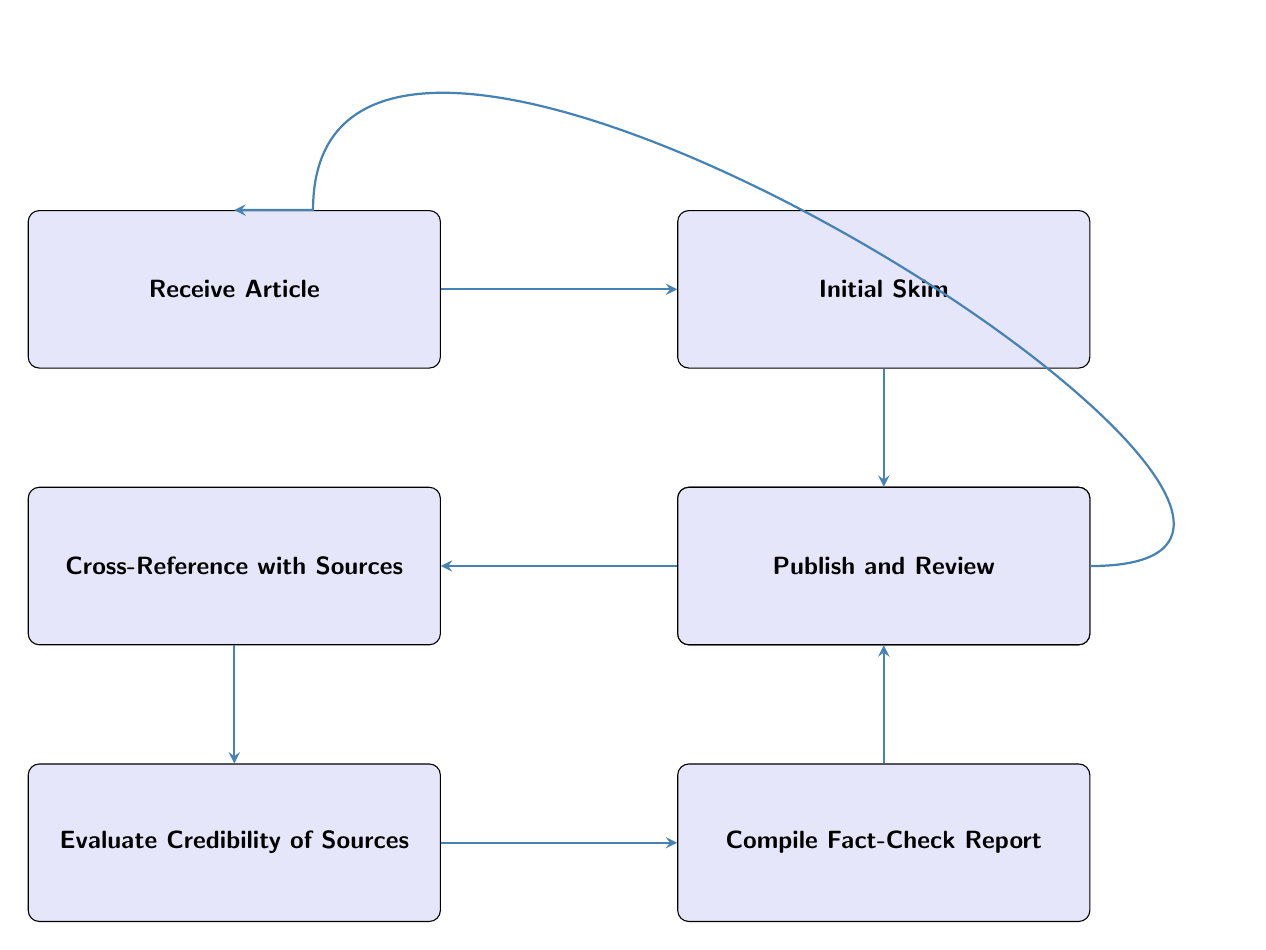What is the first step in the fact-checking workflow? The first step in the workflow, as indicated by the diagram's starting point, is to "Receive Article."
Answer: Receive Article How many steps are there in the fact-checking workflow? By counting the nodes in the diagram, we find there are a total of 7 steps represented.
Answer: 7 What step follows the "Identify Claims" node? According to the flow indicated in the diagram, the step that comes directly after "Identify Claims" is "Cross-Reference with Sources."
Answer: Cross-Reference with Sources Which tools are mentioned for the "Initial Skim" step? The diagram lists "Text Reader" and "Word Processor" as the tools used for the "Initial Skim" step.
Answer: Text Reader, Word Processor What is the last step in the fact-checking workflow? The final step, as depicted at the bottom of the diagram, is "Publish and Review."
Answer: Publish and Review Which step requires evaluating the credentials of sources? The step that necessitates evaluating the credentials of sources is "Evaluate Credibility of Sources," following the cross-referencing step.
Answer: Evaluate Credibility of Sources How are claims verified in the workflow? Claims are verified through the "Cross-Reference with Sources" step, where they are checked against credible sources.
Answer: Cross-Reference with Sources What criteria are assessed in the "Evaluate Credibility of Sources"? The criteria assessed in this step include "Author Credentials," "Peer-Reviewed Status," and "Publication Reputation."
Answer: Author Credentials, Peer-Reviewed Status, Publication Reputation What happens to the fact-check report after it is compiled? After the fact-check report is compiled, the next action is to "Publish and Review" it on designated platforms.
Answer: Publish and Review 